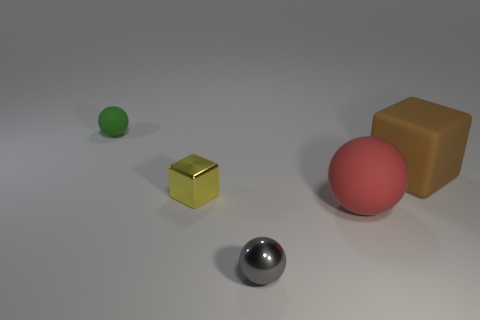How many other things are there of the same size as the yellow thing?
Provide a short and direct response. 2. What is the shape of the brown rubber thing?
Give a very brief answer. Cube. What color is the sphere that is to the left of the red rubber object and on the right side of the tiny green sphere?
Offer a terse response. Gray. What is the material of the gray object?
Provide a succinct answer. Metal. There is a gray metallic thing in front of the brown block; what is its shape?
Offer a very short reply. Sphere. The block that is the same size as the red thing is what color?
Offer a very short reply. Brown. Do the thing behind the large rubber cube and the gray thing have the same material?
Offer a terse response. No. There is a object that is behind the yellow object and left of the small gray ball; what size is it?
Provide a short and direct response. Small. There is a rubber sphere that is in front of the green sphere; how big is it?
Offer a terse response. Large. The tiny metallic thing behind the shiny object in front of the matte sphere that is right of the small metal sphere is what shape?
Make the answer very short. Cube. 